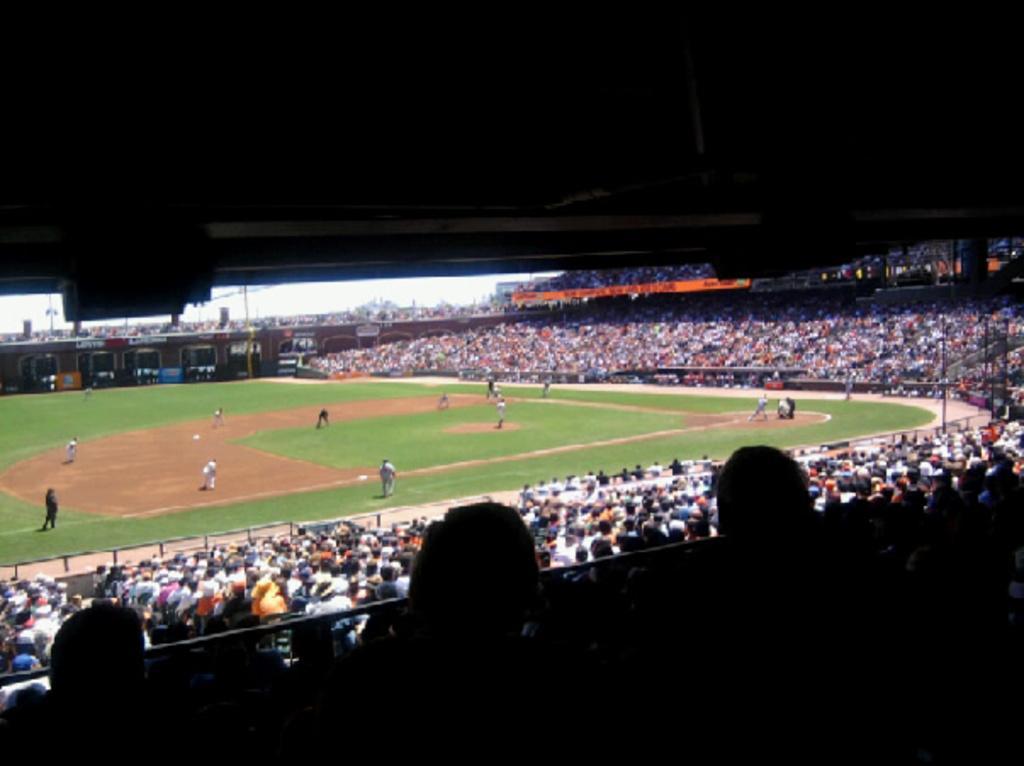How would you summarize this image in a sentence or two? The picture is clicked in a stadium. In the foreground of the picture there are audience. In the center of the picture it is a baseball ground, in the ground there are players. In the background there are audience in the stadium. Sky is sunny. 